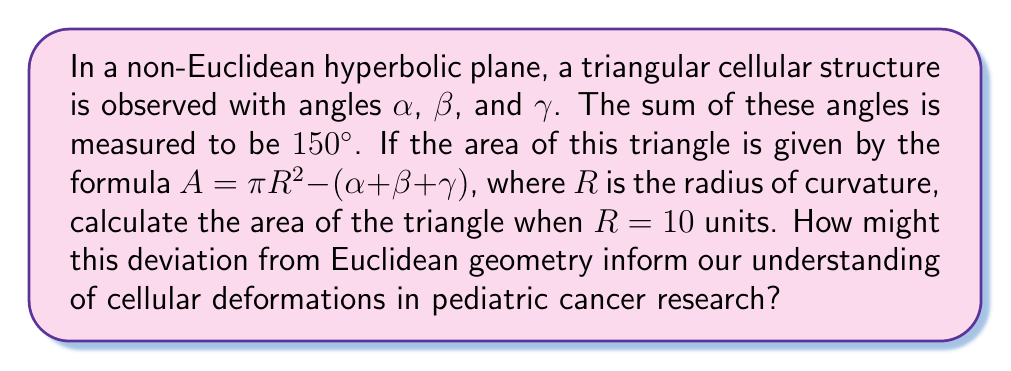Help me with this question. Let's approach this step-by-step:

1) In hyperbolic geometry, the sum of angles in a triangle is less than 180°. We're given that:

   $\alpha + \beta + \gamma = 150°$

2) The formula for the area is:

   $A = \pi R^2 - (\alpha + \beta + \gamma)$

3) We need to convert the angle sum to radians:

   $150° \times \frac{\pi}{180°} = \frac{5\pi}{6}$ radians

4) Now we can substitute the values into the area formula:

   $A = \pi R^2 - \frac{5\pi}{6}$

5) Given $R = 10$:

   $A = \pi (10)^2 - \frac{5\pi}{6}$

6) Simplify:

   $A = 100\pi - \frac{5\pi}{6}$

7) Find a common denominator:

   $A = \frac{600\pi}{6} - \frac{5\pi}{6} = \frac{595\pi}{6}$

8) This result shows how the area of the triangle in hyperbolic space differs from what we would expect in Euclidean space. In Euclidean geometry, the area would simply be zero as the angle sum would be 180°.

9) For pediatric cancer research, this non-Euclidean model could help explain cellular deformations that don't follow typical Euclidean patterns. The deviation from expected geometry might provide insights into how cancer cells distort normal tissue structures, potentially leading to new approaches for treatment or early detection.
Answer: $\frac{595\pi}{6}$ square units 